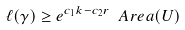<formula> <loc_0><loc_0><loc_500><loc_500>\ell ( \gamma ) \geq e ^ { c _ { 1 } k - c _ { 2 } r } \ A r e a ( U )</formula> 